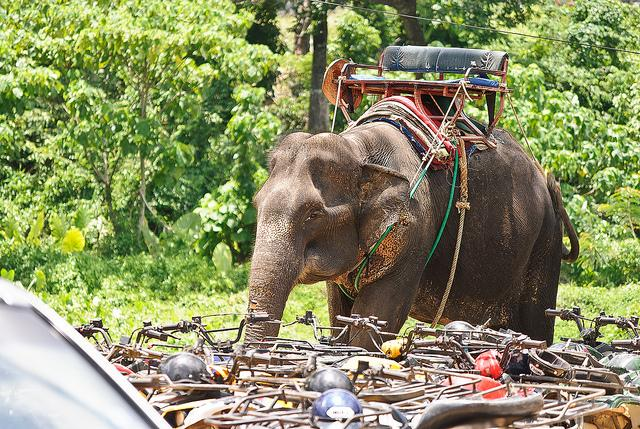What color is the back arch for the seat held by ropes on the back of this elephant? Please explain your reasoning. blue. The back arch is blue in color and is held by ropes on the back of the elephant. 